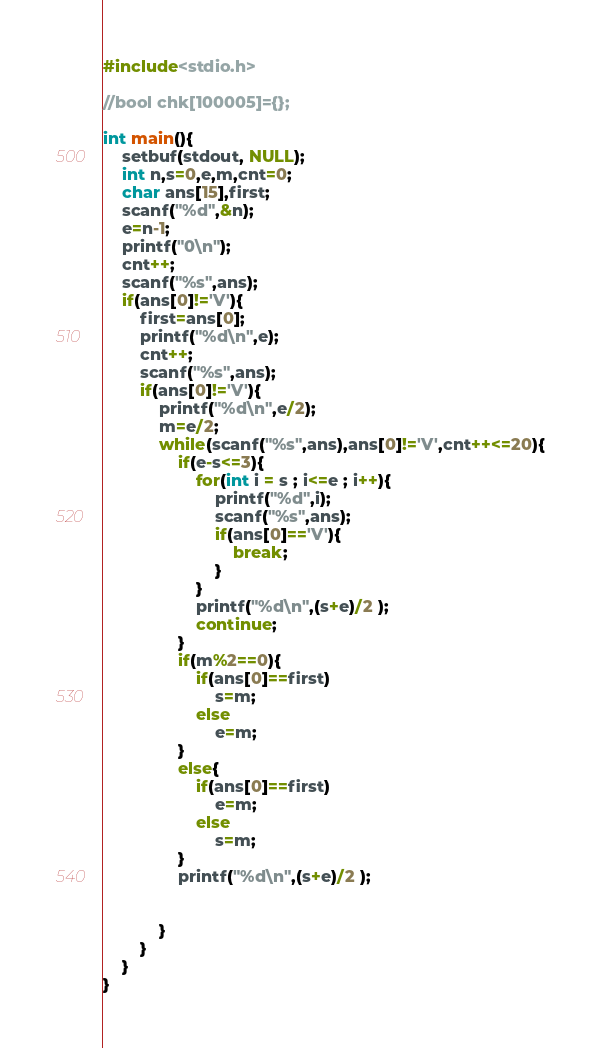Convert code to text. <code><loc_0><loc_0><loc_500><loc_500><_C_>#include<stdio.h>

//bool chk[100005]={};

int main(){
    setbuf(stdout, NULL);
    int n,s=0,e,m,cnt=0;
    char ans[15],first;
    scanf("%d",&n);
    e=n-1;
    printf("0\n");
    cnt++;
    scanf("%s",ans);
    if(ans[0]!='V'){
        first=ans[0];
        printf("%d\n",e);
        cnt++;
        scanf("%s",ans);
        if(ans[0]!='V'){
            printf("%d\n",e/2);
            m=e/2;
            while(scanf("%s",ans),ans[0]!='V',cnt++<=20){
                if(e-s<=3){
                    for(int i = s ; i<=e ; i++){
                        printf("%d",i);
                        scanf("%s",ans);
                        if(ans[0]=='V'){
                            break;
                        }
                    }
                    printf("%d\n",(s+e)/2 );
                    continue;
                }
                if(m%2==0){
                    if(ans[0]==first)
                        s=m;
                    else
                        e=m;
                }
                else{
                    if(ans[0]==first)
                        e=m;
                    else
                        s=m;
                }
                printf("%d\n",(s+e)/2 );


            }
        }
    }
}
</code> 